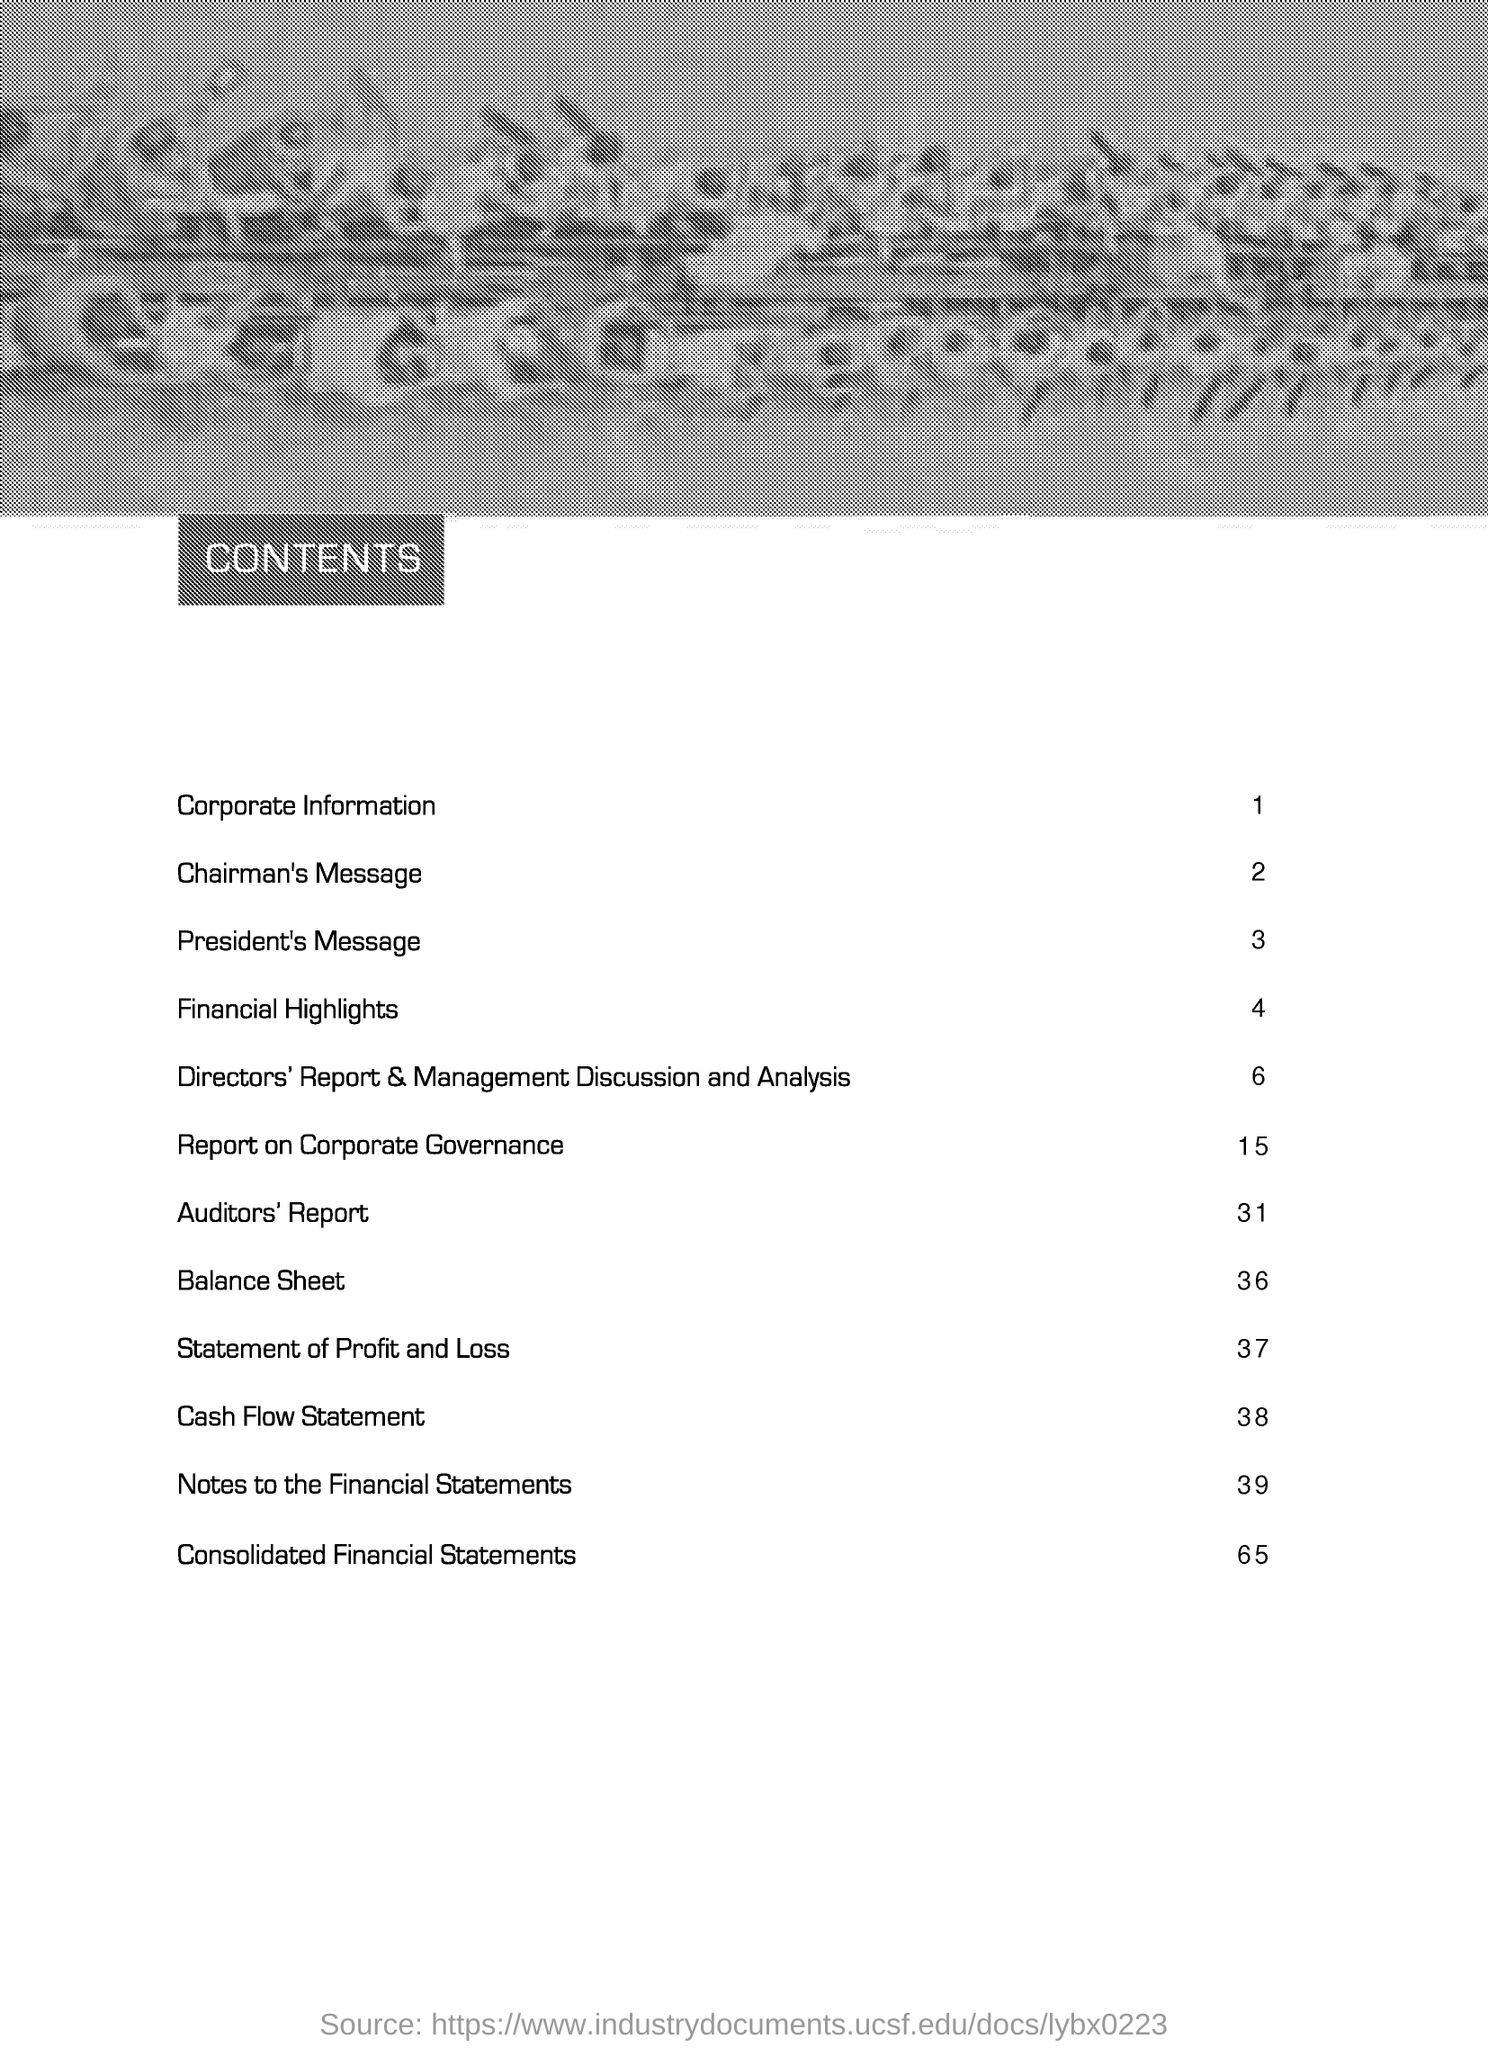What is page number of "Corporate information" as per content page?
Give a very brief answer. 1. What is page number of "Chairmans' Message" as per content page?
Offer a very short reply. 2. What is page number of "Cash Flow Statement" as per content page?
Provide a short and direct response. 38. What is page number of "Consolidated Financial Statements" as per content page?
Ensure brevity in your answer.  65. 